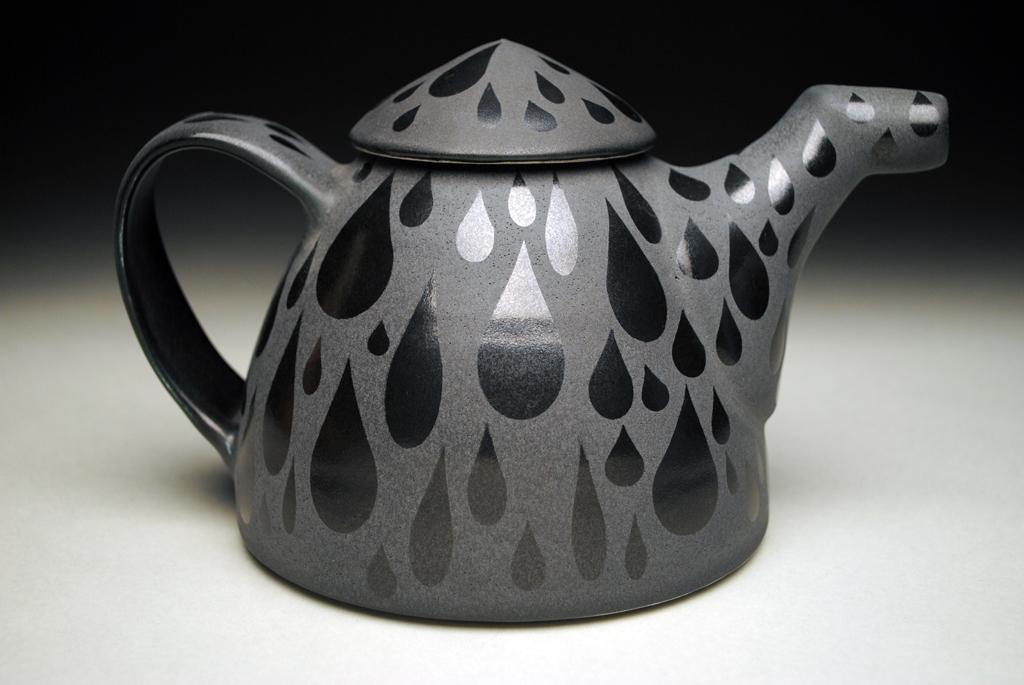What object can be seen on the floor in the image? There is a kettle on the floor in the image. What is the appearance of the kettle? The kettle has a design painted on it. What rule is being discussed in the image? There is no discussion or rule present in the image; it only features a kettle on the floor with a painted design. 